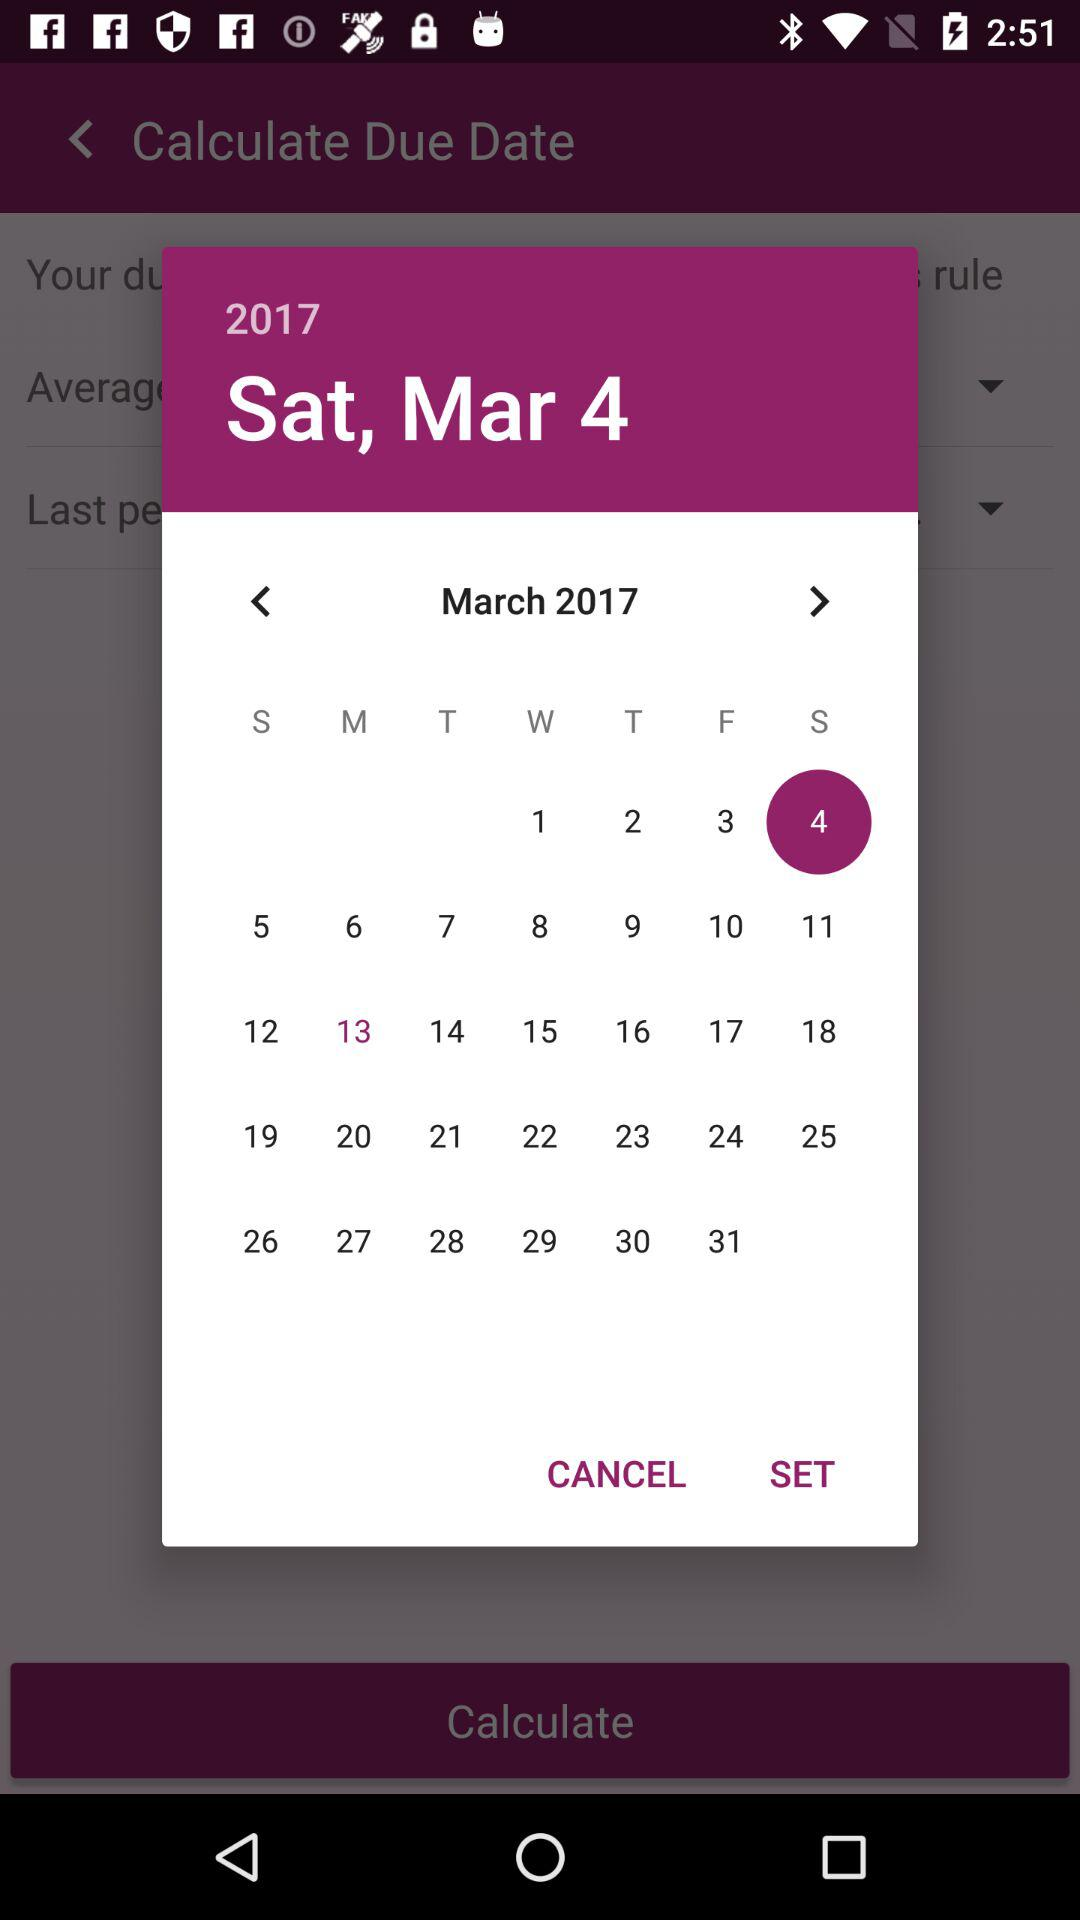What is the selected date? The selected date is March 4, 2017. 